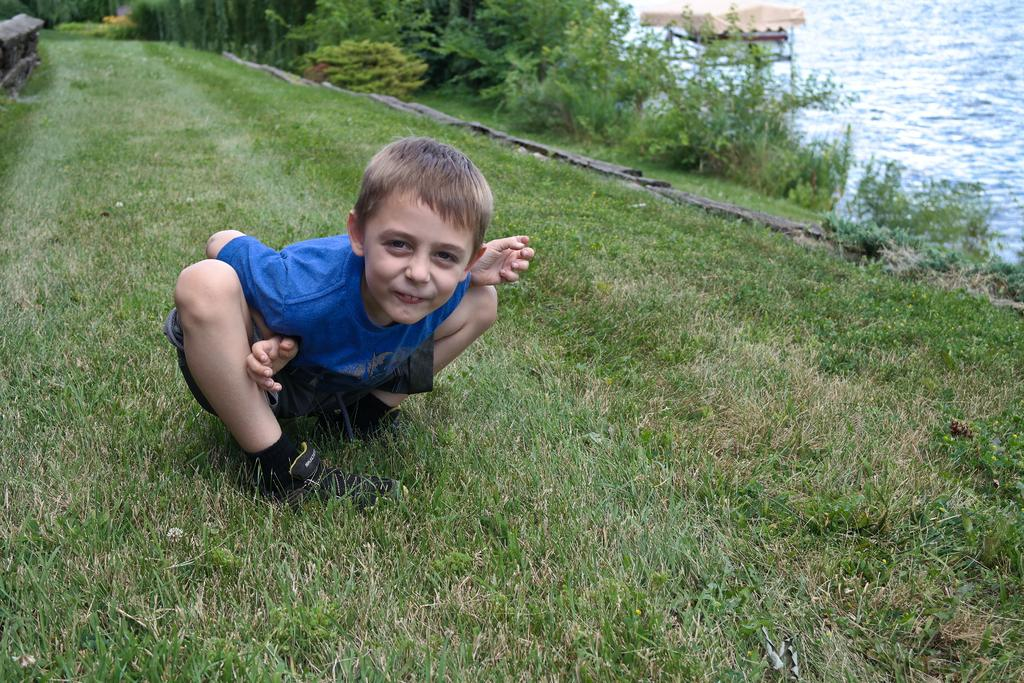Who is the main subject in the image? There is a boy in the image. Where is the boy located? The boy is on the grass. What other objects or features can be seen in the image? There is a fence, plants, and a boat in the water in the image. What can be inferred about the time of day when the image was taken? The image was likely taken during the day, as there is sufficient light to see the details clearly. What type of business is being conducted by the women in the image? There are no women present in the image, and therefore no business can be conducted by them. 